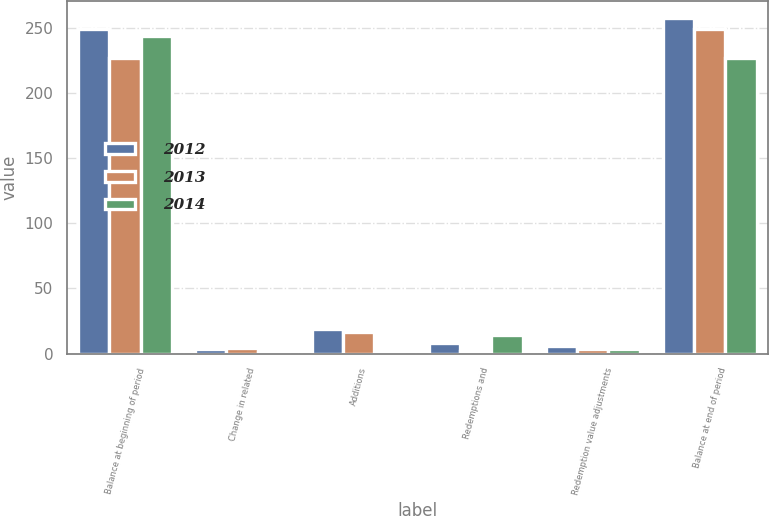Convert chart to OTSL. <chart><loc_0><loc_0><loc_500><loc_500><stacked_bar_chart><ecel><fcel>Balance at beginning of period<fcel>Change in related<fcel>Additions<fcel>Redemptions and<fcel>Redemption value adjustments<fcel>Balance at end of period<nl><fcel>2012<fcel>249.1<fcel>3.2<fcel>18.7<fcel>7.9<fcel>5.7<fcel>257.4<nl><fcel>2013<fcel>227.2<fcel>4.6<fcel>16.2<fcel>2.3<fcel>3.4<fcel>249.1<nl><fcel>2014<fcel>243.4<fcel>1.1<fcel>0<fcel>14.2<fcel>3.1<fcel>227.2<nl></chart> 